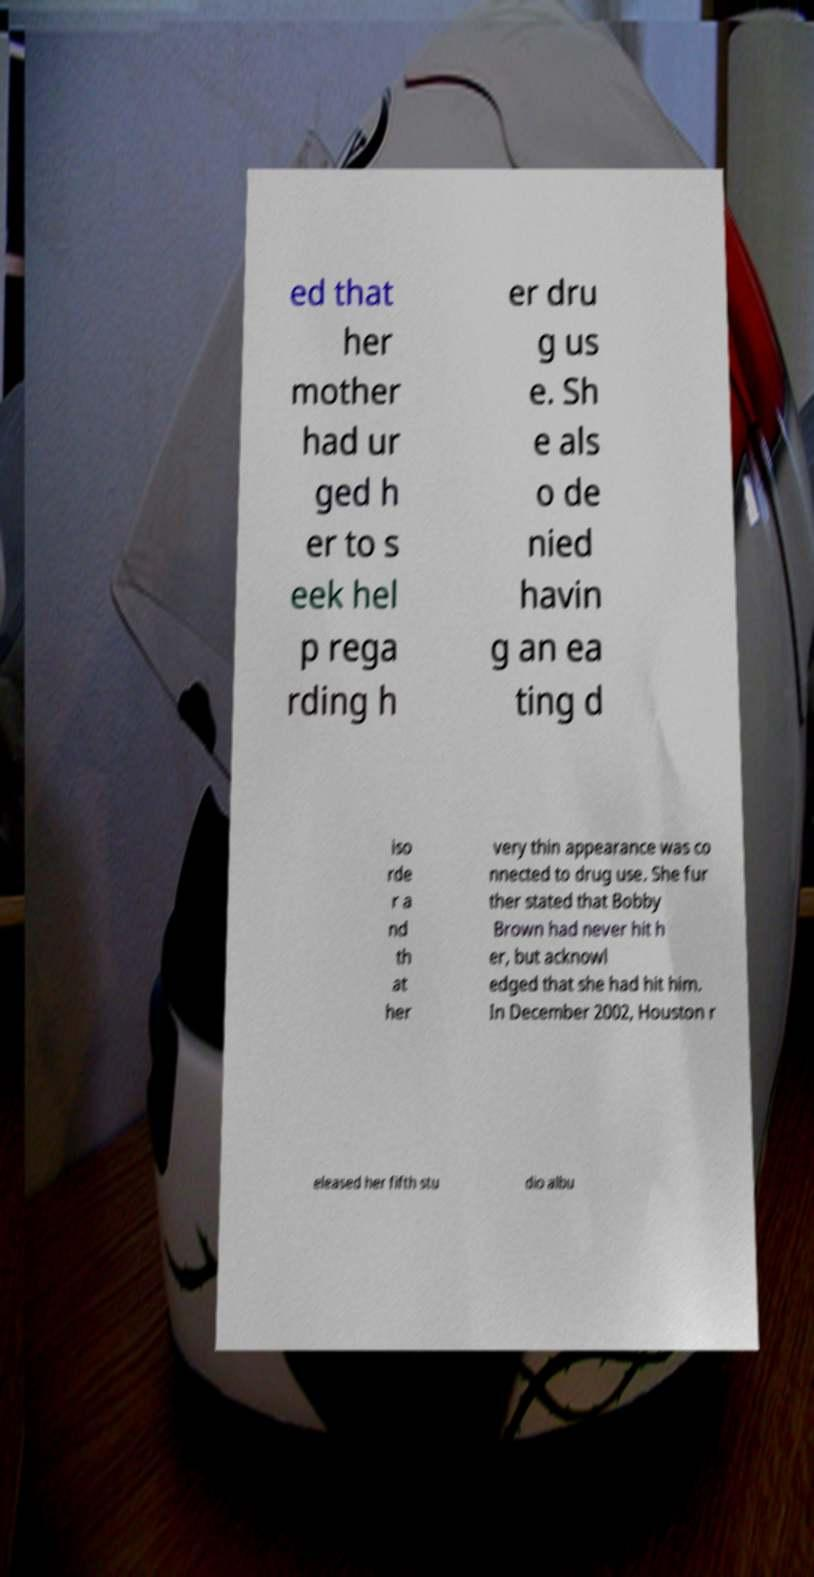Please identify and transcribe the text found in this image. ed that her mother had ur ged h er to s eek hel p rega rding h er dru g us e. Sh e als o de nied havin g an ea ting d iso rde r a nd th at her very thin appearance was co nnected to drug use. She fur ther stated that Bobby Brown had never hit h er, but acknowl edged that she had hit him. In December 2002, Houston r eleased her fifth stu dio albu 